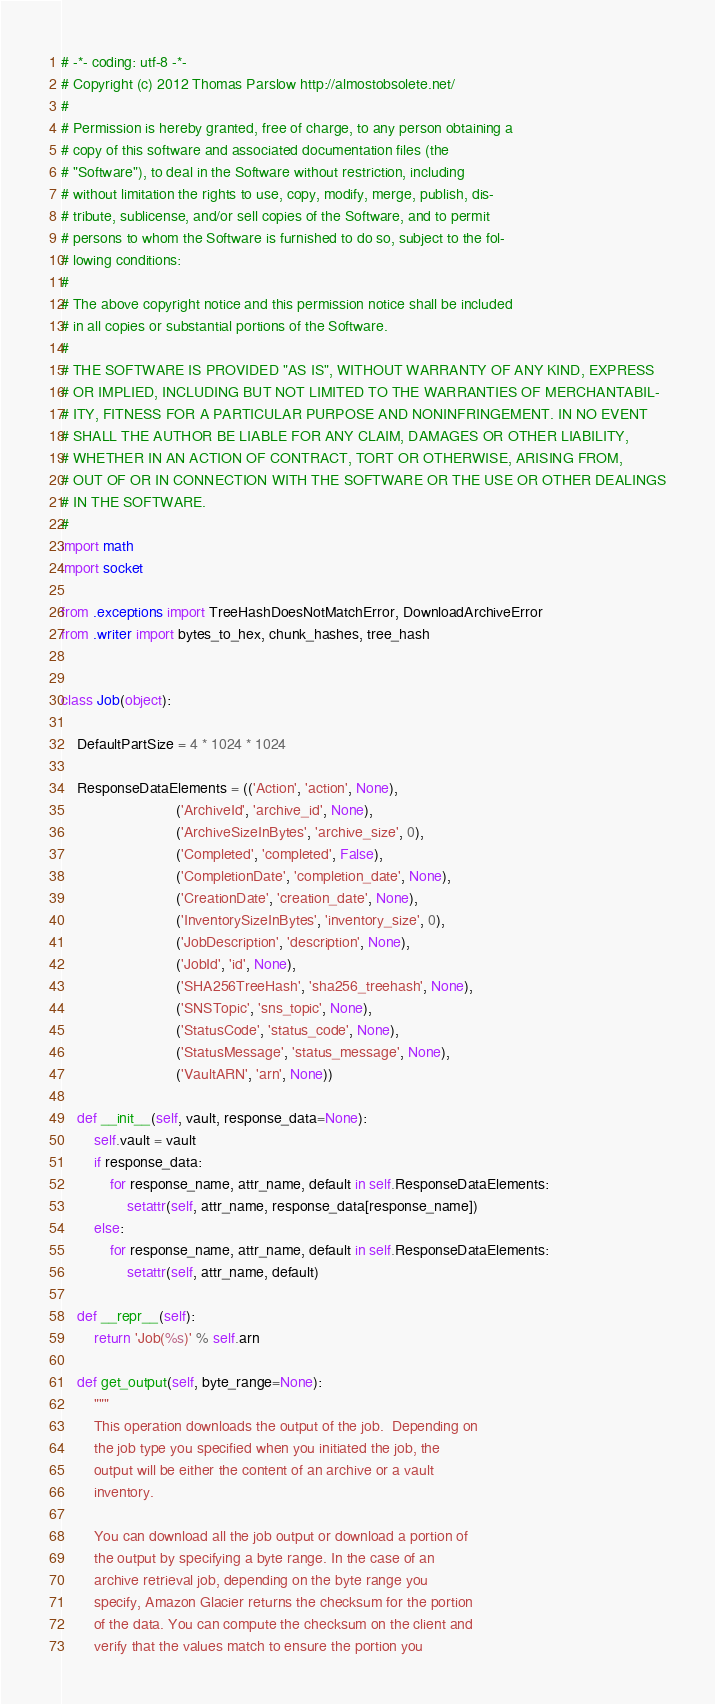Convert code to text. <code><loc_0><loc_0><loc_500><loc_500><_Python_># -*- coding: utf-8 -*-
# Copyright (c) 2012 Thomas Parslow http://almostobsolete.net/
#
# Permission is hereby granted, free of charge, to any person obtaining a
# copy of this software and associated documentation files (the
# "Software"), to deal in the Software without restriction, including
# without limitation the rights to use, copy, modify, merge, publish, dis-
# tribute, sublicense, and/or sell copies of the Software, and to permit
# persons to whom the Software is furnished to do so, subject to the fol-
# lowing conditions:
#
# The above copyright notice and this permission notice shall be included
# in all copies or substantial portions of the Software.
#
# THE SOFTWARE IS PROVIDED "AS IS", WITHOUT WARRANTY OF ANY KIND, EXPRESS
# OR IMPLIED, INCLUDING BUT NOT LIMITED TO THE WARRANTIES OF MERCHANTABIL-
# ITY, FITNESS FOR A PARTICULAR PURPOSE AND NONINFRINGEMENT. IN NO EVENT
# SHALL THE AUTHOR BE LIABLE FOR ANY CLAIM, DAMAGES OR OTHER LIABILITY,
# WHETHER IN AN ACTION OF CONTRACT, TORT OR OTHERWISE, ARISING FROM,
# OUT OF OR IN CONNECTION WITH THE SOFTWARE OR THE USE OR OTHER DEALINGS
# IN THE SOFTWARE.
#
import math
import socket

from .exceptions import TreeHashDoesNotMatchError, DownloadArchiveError
from .writer import bytes_to_hex, chunk_hashes, tree_hash


class Job(object):

    DefaultPartSize = 4 * 1024 * 1024

    ResponseDataElements = (('Action', 'action', None),
                            ('ArchiveId', 'archive_id', None),
                            ('ArchiveSizeInBytes', 'archive_size', 0),
                            ('Completed', 'completed', False),
                            ('CompletionDate', 'completion_date', None),
                            ('CreationDate', 'creation_date', None),
                            ('InventorySizeInBytes', 'inventory_size', 0),
                            ('JobDescription', 'description', None),
                            ('JobId', 'id', None),
                            ('SHA256TreeHash', 'sha256_treehash', None),
                            ('SNSTopic', 'sns_topic', None),
                            ('StatusCode', 'status_code', None),
                            ('StatusMessage', 'status_message', None),
                            ('VaultARN', 'arn', None))

    def __init__(self, vault, response_data=None):
        self.vault = vault
        if response_data:
            for response_name, attr_name, default in self.ResponseDataElements:
                setattr(self, attr_name, response_data[response_name])
        else:
            for response_name, attr_name, default in self.ResponseDataElements:
                setattr(self, attr_name, default)

    def __repr__(self):
        return 'Job(%s)' % self.arn

    def get_output(self, byte_range=None):
        """
        This operation downloads the output of the job.  Depending on
        the job type you specified when you initiated the job, the
        output will be either the content of an archive or a vault
        inventory.

        You can download all the job output or download a portion of
        the output by specifying a byte range. In the case of an
        archive retrieval job, depending on the byte range you
        specify, Amazon Glacier returns the checksum for the portion
        of the data. You can compute the checksum on the client and
        verify that the values match to ensure the portion you</code> 